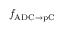<formula> <loc_0><loc_0><loc_500><loc_500>f _ { A D C \to p C }</formula> 